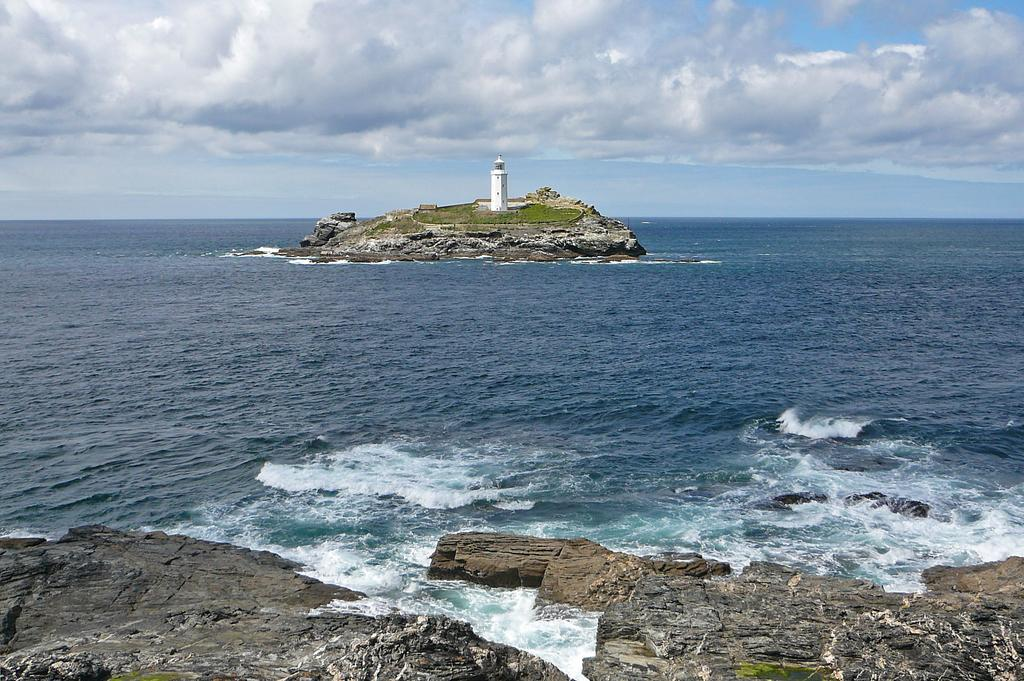What type of natural feature is visible in the image? There is a sea in the image. What other objects or features can be seen in the image? There are rocks, a lighthouse, and grass visible in the image. What is the condition of the sky in the image? The sky is cloudy in the image. What type of shirt is being worn by the fork in the image? There is no shirt or fork present in the image. 